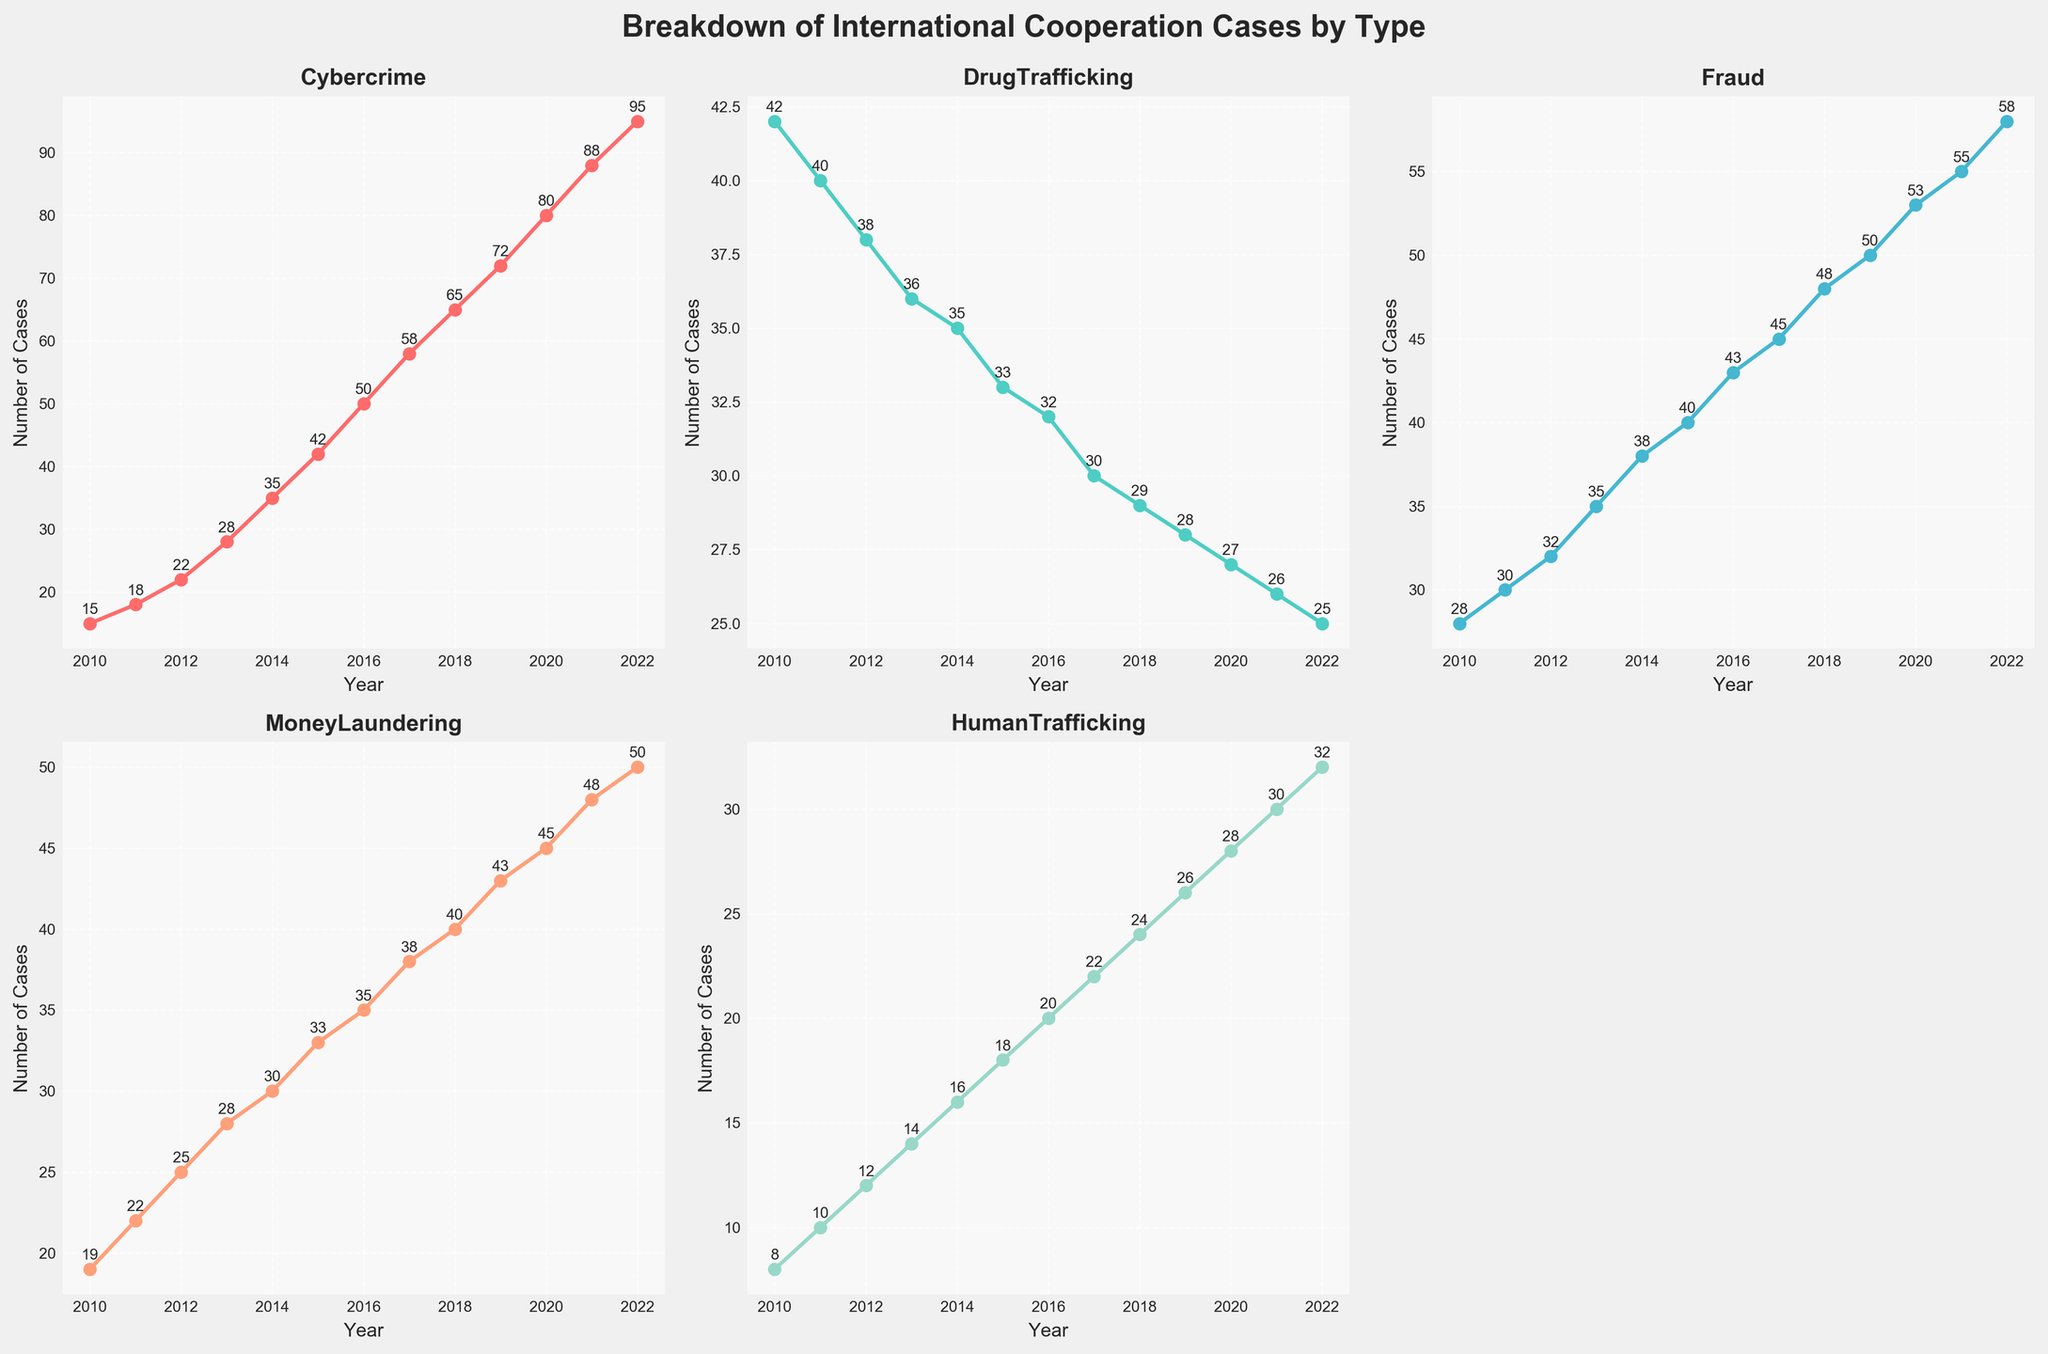What year had the highest number of Cybercrime cases? The Cybercrime subplot shows the highest number of cases at the rightmost year, which is 2022, with 95 cases.
Answer: 2022 How does the trend of Drug Trafficking cases compare to that of Fraud cases from 2010 to 2022? The Drug Trafficking subplot shows a decreasing trend starting at 42 cases in 2010 and ending at 25 cases in 2022. In contrast, the Fraud subplot shows an increasing trend starting at 28 cases in 2010 and ending at 58 cases in 2022.
Answer: Drug Trafficking decreases, Fraud increases Which year had the smallest number of Human Trafficking cases, and what was the count? The Human Trafficking subplot shows the smallest number of cases at the leftmost year, which is 2010 with 8 cases.
Answer: 2010, 8 What was the average number of Money Laundering cases between 2010 and 2015 inclusive? The Money Laundering subplot shows the cases for 2010 through 2015 as 19, 22, 25, 28, 30, and 33. Summing these gives (19 + 22 + 25 + 28 + 30 + 33) = 157, and the average is 157/6 ≈ 26.17.
Answer: 26.17 Compare the increase in Cybercrime cases from 2010 to 2022 to the increase in Fraud cases within the same period. The Cybercrime subplot shows an increase from 15 cases in 2010 to 95 cases in 2022, a difference of 80 cases. The Fraud subplot shows an increase from 28 cases in 2010 to 58 cases in 2022, a difference of 30 cases. Thus, the increase in Cybercrime cases (80) is greater than the increase in Fraud cases (30).
Answer: Cybercrime +80, Fraud +30 Which category had the most stable number of cases over the years? The trend lines show that Drug Trafficking cases have the least variation, starting at 42 cases in 2010 and decreasing steadily to 25 cases in 2022, indicating more stability compared to other categories.
Answer: Drug Trafficking Calculate the sum of Cybercrime and Human Trafficking cases in 2020. The Cybercrime subplot shows 80 cases and the Human Trafficking subplot shows 28 cases in 2020. Summing these gives 80 + 28 = 108 cases.
Answer: 108 What can you infer about the trend for Money Laundering cases from 2010 to 2022? The Money Laundering subplot shows an upward trend, starting at 19 cases in 2010 and increasing to 50 cases in 2022, indicating a steady rise over the years.
Answer: Increasing trend Which year saw the same number of Fraud and Money Laundering cases, and what was the count? The Fraud and Money Laundering subplots intersect in 2013, both showing 35 cases for that year.
Answer: 2013, 35 